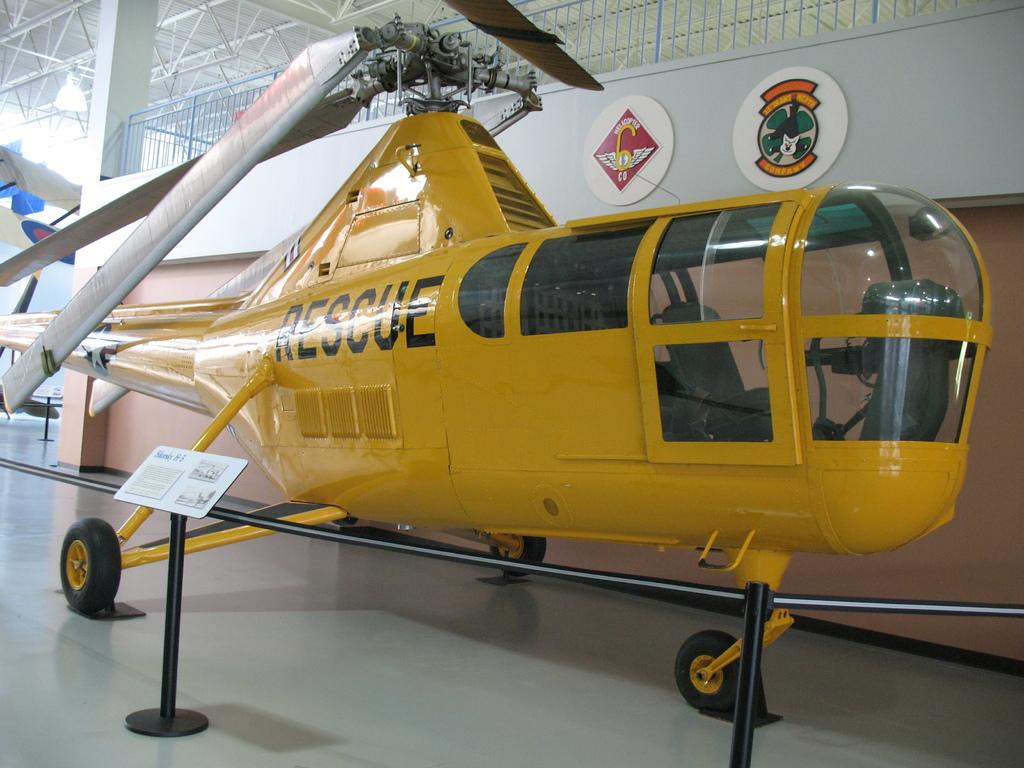<image>
Give a short and clear explanation of the subsequent image. A yellow Rescue helicopter is displayed behind ropes. 